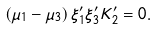Convert formula to latex. <formula><loc_0><loc_0><loc_500><loc_500>\left ( \mu _ { 1 } - \mu _ { 3 } \right ) \xi _ { 1 } ^ { \prime } \xi _ { 3 } ^ { \prime } K _ { 2 } ^ { \prime } = 0 .</formula> 